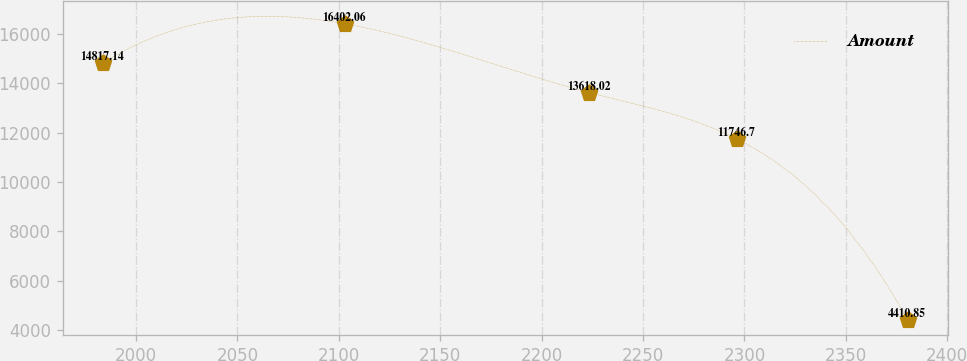Convert chart. <chart><loc_0><loc_0><loc_500><loc_500><line_chart><ecel><fcel>Amount<nl><fcel>1983.73<fcel>14817.1<nl><fcel>2103.14<fcel>16402.1<nl><fcel>2223.5<fcel>13618<nl><fcel>2296.17<fcel>11746.7<nl><fcel>2380.54<fcel>4410.85<nl></chart> 